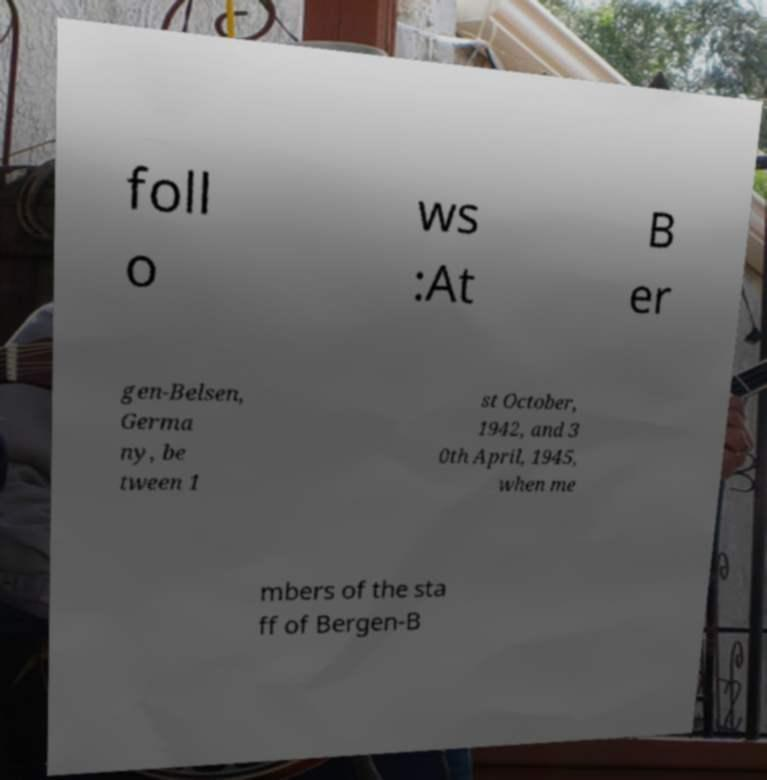There's text embedded in this image that I need extracted. Can you transcribe it verbatim? foll o ws :At B er gen-Belsen, Germa ny, be tween 1 st October, 1942, and 3 0th April, 1945, when me mbers of the sta ff of Bergen-B 